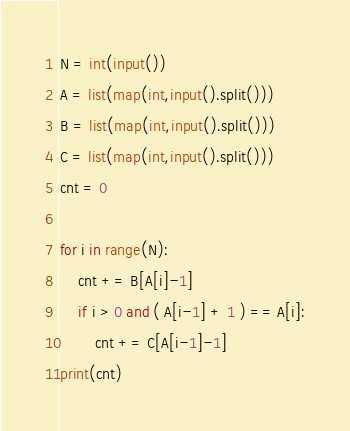<code> <loc_0><loc_0><loc_500><loc_500><_Python_>N = int(input())
A = list(map(int,input().split()))
B = list(map(int,input().split()))
C = list(map(int,input().split()))
cnt = 0

for i in range(N):
    cnt += B[A[i]-1]
    if i > 0 and ( A[i-1] + 1 ) == A[i]:
        cnt += C[A[i-1]-1]
print(cnt)</code> 